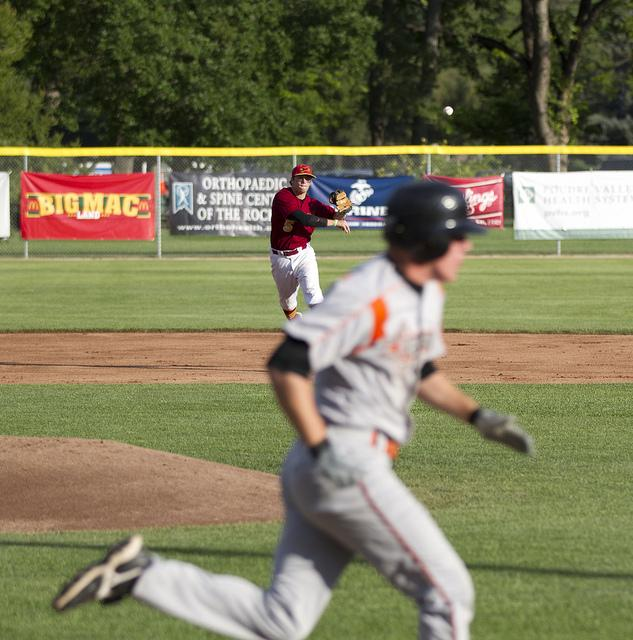Why is the player blurry? he's running 